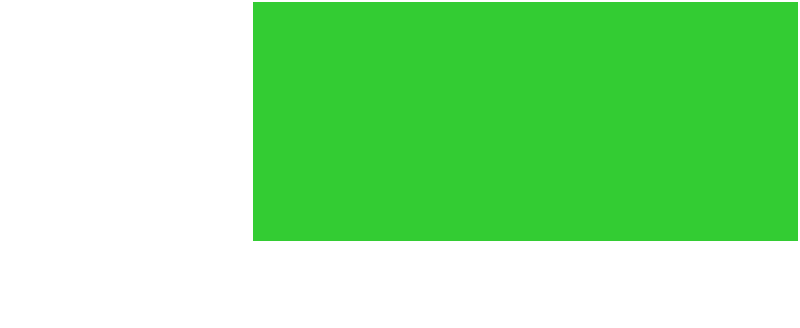As a football fan who appreciates the complexities of the game, including the field dimensions, calculate the area of a standard American football field. The field measures 120 yards in length and 53.3 yards in width. Express your answer in square yards, rounded to the nearest whole number. To calculate the area of the football field, we need to multiply its length by its width. Let's break it down step by step:

1. Given dimensions:
   Length = 120 yards
   Width = 53.3 yards

2. Area formula for a rectangle:
   $$ \text{Area} = \text{Length} \times \text{Width} $$

3. Substituting the values:
   $$ \text{Area} = 120 \text{ yards} \times 53.3 \text{ yards} $$

4. Calculating:
   $$ \text{Area} = 6,396 \text{ square yards} $$

5. Rounding to the nearest whole number:
   $$ \text{Area} \approx 6,396 \text{ square yards} $$

Note: As a football fan who tends to be lenient with referees' errors, it's worth mentioning that slight variations in field measurements due to weather conditions or maintenance might occur, but they generally don't significantly impact the game or official calculations.
Answer: 6,396 square yards 